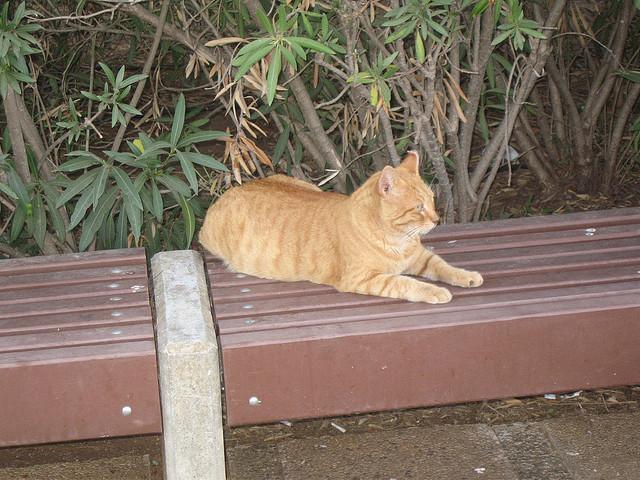What word describes this animal?
Pick the right solution, then justify: 'Answer: answer
Rationale: rationale.'
Options: Canine, bovine, equine, feline. Answer: feline.
Rationale: This is a feline cat. 